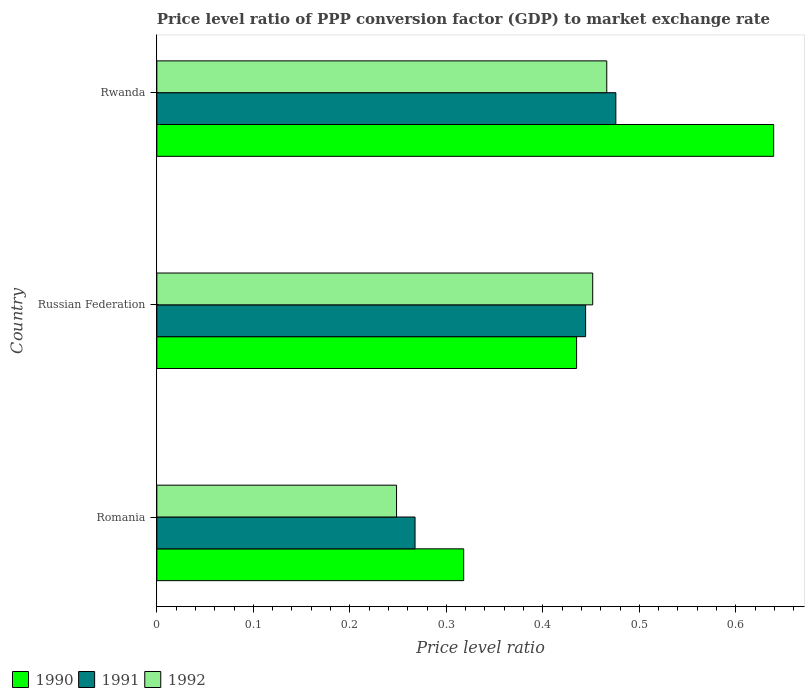Are the number of bars per tick equal to the number of legend labels?
Offer a terse response. Yes. How many bars are there on the 1st tick from the bottom?
Offer a very short reply. 3. What is the label of the 3rd group of bars from the top?
Provide a succinct answer. Romania. What is the price level ratio in 1990 in Romania?
Your answer should be very brief. 0.32. Across all countries, what is the maximum price level ratio in 1992?
Make the answer very short. 0.47. Across all countries, what is the minimum price level ratio in 1991?
Keep it short and to the point. 0.27. In which country was the price level ratio in 1990 maximum?
Keep it short and to the point. Rwanda. In which country was the price level ratio in 1990 minimum?
Make the answer very short. Romania. What is the total price level ratio in 1991 in the graph?
Keep it short and to the point. 1.19. What is the difference between the price level ratio in 1990 in Romania and that in Rwanda?
Offer a very short reply. -0.32. What is the difference between the price level ratio in 1990 in Romania and the price level ratio in 1991 in Rwanda?
Provide a succinct answer. -0.16. What is the average price level ratio in 1991 per country?
Offer a very short reply. 0.4. What is the difference between the price level ratio in 1991 and price level ratio in 1990 in Rwanda?
Make the answer very short. -0.16. In how many countries, is the price level ratio in 1991 greater than 0.48000000000000004 ?
Keep it short and to the point. 0. What is the ratio of the price level ratio in 1992 in Romania to that in Rwanda?
Make the answer very short. 0.53. What is the difference between the highest and the second highest price level ratio in 1991?
Make the answer very short. 0.03. What is the difference between the highest and the lowest price level ratio in 1992?
Your response must be concise. 0.22. In how many countries, is the price level ratio in 1992 greater than the average price level ratio in 1992 taken over all countries?
Offer a very short reply. 2. What does the 1st bar from the top in Russian Federation represents?
Offer a very short reply. 1992. What does the 2nd bar from the bottom in Romania represents?
Offer a terse response. 1991. Is it the case that in every country, the sum of the price level ratio in 1991 and price level ratio in 1990 is greater than the price level ratio in 1992?
Keep it short and to the point. Yes. Are all the bars in the graph horizontal?
Give a very brief answer. Yes. What is the difference between two consecutive major ticks on the X-axis?
Provide a short and direct response. 0.1. Are the values on the major ticks of X-axis written in scientific E-notation?
Your answer should be very brief. No. Does the graph contain any zero values?
Your answer should be compact. No. Does the graph contain grids?
Provide a short and direct response. No. Where does the legend appear in the graph?
Provide a succinct answer. Bottom left. How are the legend labels stacked?
Your response must be concise. Horizontal. What is the title of the graph?
Keep it short and to the point. Price level ratio of PPP conversion factor (GDP) to market exchange rate. What is the label or title of the X-axis?
Give a very brief answer. Price level ratio. What is the Price level ratio of 1990 in Romania?
Your answer should be compact. 0.32. What is the Price level ratio in 1991 in Romania?
Give a very brief answer. 0.27. What is the Price level ratio in 1992 in Romania?
Your answer should be compact. 0.25. What is the Price level ratio of 1990 in Russian Federation?
Give a very brief answer. 0.43. What is the Price level ratio in 1991 in Russian Federation?
Provide a succinct answer. 0.44. What is the Price level ratio of 1992 in Russian Federation?
Offer a terse response. 0.45. What is the Price level ratio of 1990 in Rwanda?
Your response must be concise. 0.64. What is the Price level ratio of 1991 in Rwanda?
Keep it short and to the point. 0.48. What is the Price level ratio in 1992 in Rwanda?
Offer a terse response. 0.47. Across all countries, what is the maximum Price level ratio in 1990?
Keep it short and to the point. 0.64. Across all countries, what is the maximum Price level ratio of 1991?
Your answer should be compact. 0.48. Across all countries, what is the maximum Price level ratio in 1992?
Provide a succinct answer. 0.47. Across all countries, what is the minimum Price level ratio of 1990?
Offer a very short reply. 0.32. Across all countries, what is the minimum Price level ratio of 1991?
Provide a short and direct response. 0.27. Across all countries, what is the minimum Price level ratio in 1992?
Your response must be concise. 0.25. What is the total Price level ratio of 1990 in the graph?
Keep it short and to the point. 1.39. What is the total Price level ratio in 1991 in the graph?
Your answer should be very brief. 1.19. What is the total Price level ratio in 1992 in the graph?
Make the answer very short. 1.17. What is the difference between the Price level ratio of 1990 in Romania and that in Russian Federation?
Keep it short and to the point. -0.12. What is the difference between the Price level ratio of 1991 in Romania and that in Russian Federation?
Make the answer very short. -0.18. What is the difference between the Price level ratio of 1992 in Romania and that in Russian Federation?
Make the answer very short. -0.2. What is the difference between the Price level ratio in 1990 in Romania and that in Rwanda?
Offer a terse response. -0.32. What is the difference between the Price level ratio in 1991 in Romania and that in Rwanda?
Keep it short and to the point. -0.21. What is the difference between the Price level ratio in 1992 in Romania and that in Rwanda?
Provide a succinct answer. -0.22. What is the difference between the Price level ratio in 1990 in Russian Federation and that in Rwanda?
Give a very brief answer. -0.2. What is the difference between the Price level ratio of 1991 in Russian Federation and that in Rwanda?
Provide a succinct answer. -0.03. What is the difference between the Price level ratio of 1992 in Russian Federation and that in Rwanda?
Your response must be concise. -0.01. What is the difference between the Price level ratio of 1990 in Romania and the Price level ratio of 1991 in Russian Federation?
Provide a short and direct response. -0.13. What is the difference between the Price level ratio of 1990 in Romania and the Price level ratio of 1992 in Russian Federation?
Provide a short and direct response. -0.13. What is the difference between the Price level ratio of 1991 in Romania and the Price level ratio of 1992 in Russian Federation?
Offer a very short reply. -0.18. What is the difference between the Price level ratio in 1990 in Romania and the Price level ratio in 1991 in Rwanda?
Offer a very short reply. -0.16. What is the difference between the Price level ratio of 1990 in Romania and the Price level ratio of 1992 in Rwanda?
Provide a succinct answer. -0.15. What is the difference between the Price level ratio of 1991 in Romania and the Price level ratio of 1992 in Rwanda?
Offer a terse response. -0.2. What is the difference between the Price level ratio in 1990 in Russian Federation and the Price level ratio in 1991 in Rwanda?
Give a very brief answer. -0.04. What is the difference between the Price level ratio of 1990 in Russian Federation and the Price level ratio of 1992 in Rwanda?
Make the answer very short. -0.03. What is the difference between the Price level ratio of 1991 in Russian Federation and the Price level ratio of 1992 in Rwanda?
Give a very brief answer. -0.02. What is the average Price level ratio in 1990 per country?
Offer a terse response. 0.46. What is the average Price level ratio in 1991 per country?
Provide a short and direct response. 0.4. What is the average Price level ratio in 1992 per country?
Ensure brevity in your answer.  0.39. What is the difference between the Price level ratio in 1990 and Price level ratio in 1991 in Romania?
Offer a terse response. 0.05. What is the difference between the Price level ratio in 1990 and Price level ratio in 1992 in Romania?
Your answer should be very brief. 0.07. What is the difference between the Price level ratio of 1991 and Price level ratio of 1992 in Romania?
Your answer should be very brief. 0.02. What is the difference between the Price level ratio in 1990 and Price level ratio in 1991 in Russian Federation?
Your response must be concise. -0.01. What is the difference between the Price level ratio of 1990 and Price level ratio of 1992 in Russian Federation?
Keep it short and to the point. -0.02. What is the difference between the Price level ratio in 1991 and Price level ratio in 1992 in Russian Federation?
Offer a terse response. -0.01. What is the difference between the Price level ratio in 1990 and Price level ratio in 1991 in Rwanda?
Keep it short and to the point. 0.16. What is the difference between the Price level ratio in 1990 and Price level ratio in 1992 in Rwanda?
Keep it short and to the point. 0.17. What is the difference between the Price level ratio in 1991 and Price level ratio in 1992 in Rwanda?
Provide a succinct answer. 0.01. What is the ratio of the Price level ratio in 1990 in Romania to that in Russian Federation?
Ensure brevity in your answer.  0.73. What is the ratio of the Price level ratio in 1991 in Romania to that in Russian Federation?
Give a very brief answer. 0.6. What is the ratio of the Price level ratio in 1992 in Romania to that in Russian Federation?
Provide a short and direct response. 0.55. What is the ratio of the Price level ratio of 1990 in Romania to that in Rwanda?
Offer a very short reply. 0.5. What is the ratio of the Price level ratio of 1991 in Romania to that in Rwanda?
Offer a very short reply. 0.56. What is the ratio of the Price level ratio in 1992 in Romania to that in Rwanda?
Give a very brief answer. 0.53. What is the ratio of the Price level ratio of 1990 in Russian Federation to that in Rwanda?
Your answer should be very brief. 0.68. What is the ratio of the Price level ratio in 1991 in Russian Federation to that in Rwanda?
Make the answer very short. 0.93. What is the ratio of the Price level ratio in 1992 in Russian Federation to that in Rwanda?
Provide a short and direct response. 0.97. What is the difference between the highest and the second highest Price level ratio in 1990?
Offer a very short reply. 0.2. What is the difference between the highest and the second highest Price level ratio of 1991?
Provide a succinct answer. 0.03. What is the difference between the highest and the second highest Price level ratio of 1992?
Offer a terse response. 0.01. What is the difference between the highest and the lowest Price level ratio of 1990?
Ensure brevity in your answer.  0.32. What is the difference between the highest and the lowest Price level ratio of 1991?
Provide a short and direct response. 0.21. What is the difference between the highest and the lowest Price level ratio of 1992?
Offer a very short reply. 0.22. 